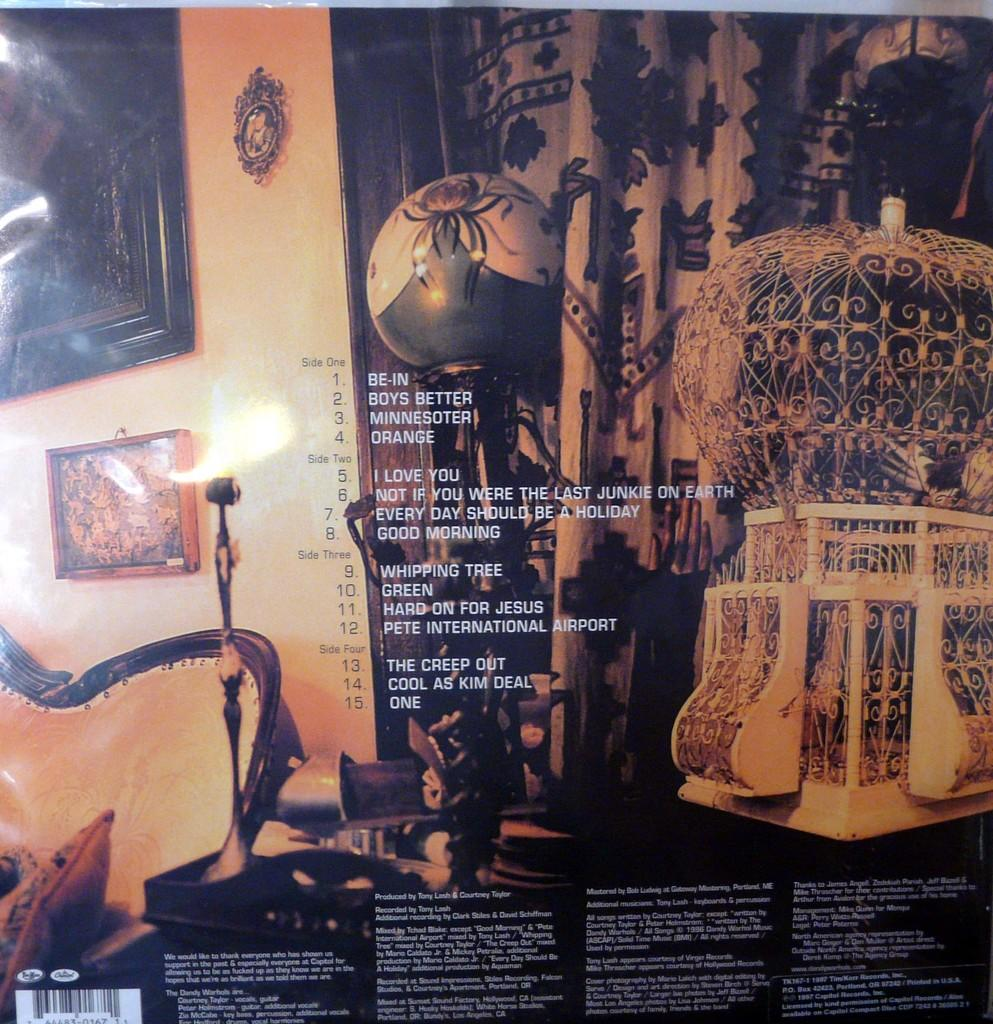<image>
Create a compact narrative representing the image presented. The back of an album cover for the group the Dandy Warhols. 